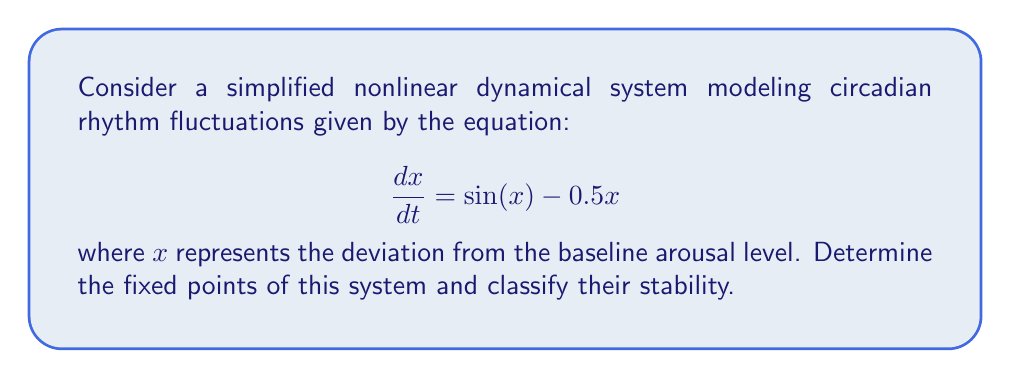Help me with this question. To find the fixed points of the system, we set the derivative to zero:

1) $\frac{dx}{dt} = 0$
   $\sin(x) - 0.5x = 0$

2) This transcendental equation cannot be solved algebraically. However, we can identify solutions graphically or numerically.

3) Graphically, the fixed points occur where the curves $y = \sin(x)$ and $y = 0.5x$ intersect.

4) We can see that $x = 0$ is always a solution. For other solutions:
   $\sin(x) = 0.5x$

5) Using numerical methods or graphing, we find three fixed points:
   $x_1 = 0$, $x_2 \approx 1.895$, and $x_3 \approx -1.895$

6) To classify stability, we evaluate the derivative of $\frac{dx}{dt}$ at each fixed point:
   $\frac{d}{dx}(\sin(x) - 0.5x) = \cos(x) - 0.5$

7) At $x_1 = 0$: $\cos(0) - 0.5 = 0.5 > 0$, so this is an unstable fixed point.
   At $x_2 \approx 1.895$: $\cos(1.895) - 0.5 \approx -0.5 < 0$, so this is a stable fixed point.
   At $x_3 \approx -1.895$: $\cos(-1.895) - 0.5 \approx -0.5 < 0$, so this is also a stable fixed point.

8) The stable fixed points represent steady states in the circadian rhythm, while the unstable fixed point represents a threshold between the two stable states.
Answer: Fixed points: $x_1 = 0$ (unstable), $x_2 \approx 1.895$ (stable), $x_3 \approx -1.895$ (stable) 